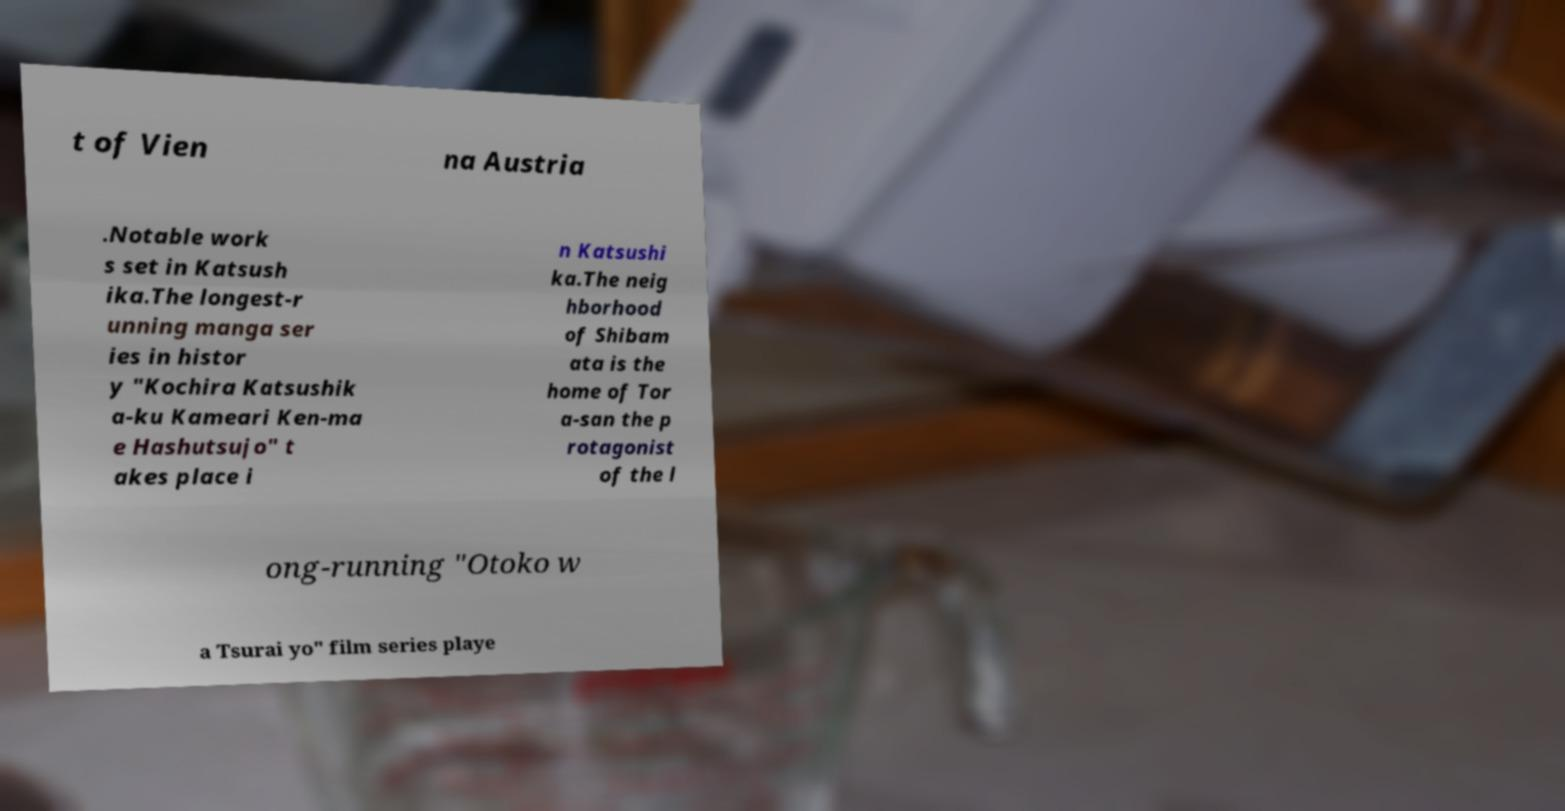Please read and relay the text visible in this image. What does it say? t of Vien na Austria .Notable work s set in Katsush ika.The longest-r unning manga ser ies in histor y "Kochira Katsushik a-ku Kameari Ken-ma e Hashutsujo" t akes place i n Katsushi ka.The neig hborhood of Shibam ata is the home of Tor a-san the p rotagonist of the l ong-running "Otoko w a Tsurai yo" film series playe 